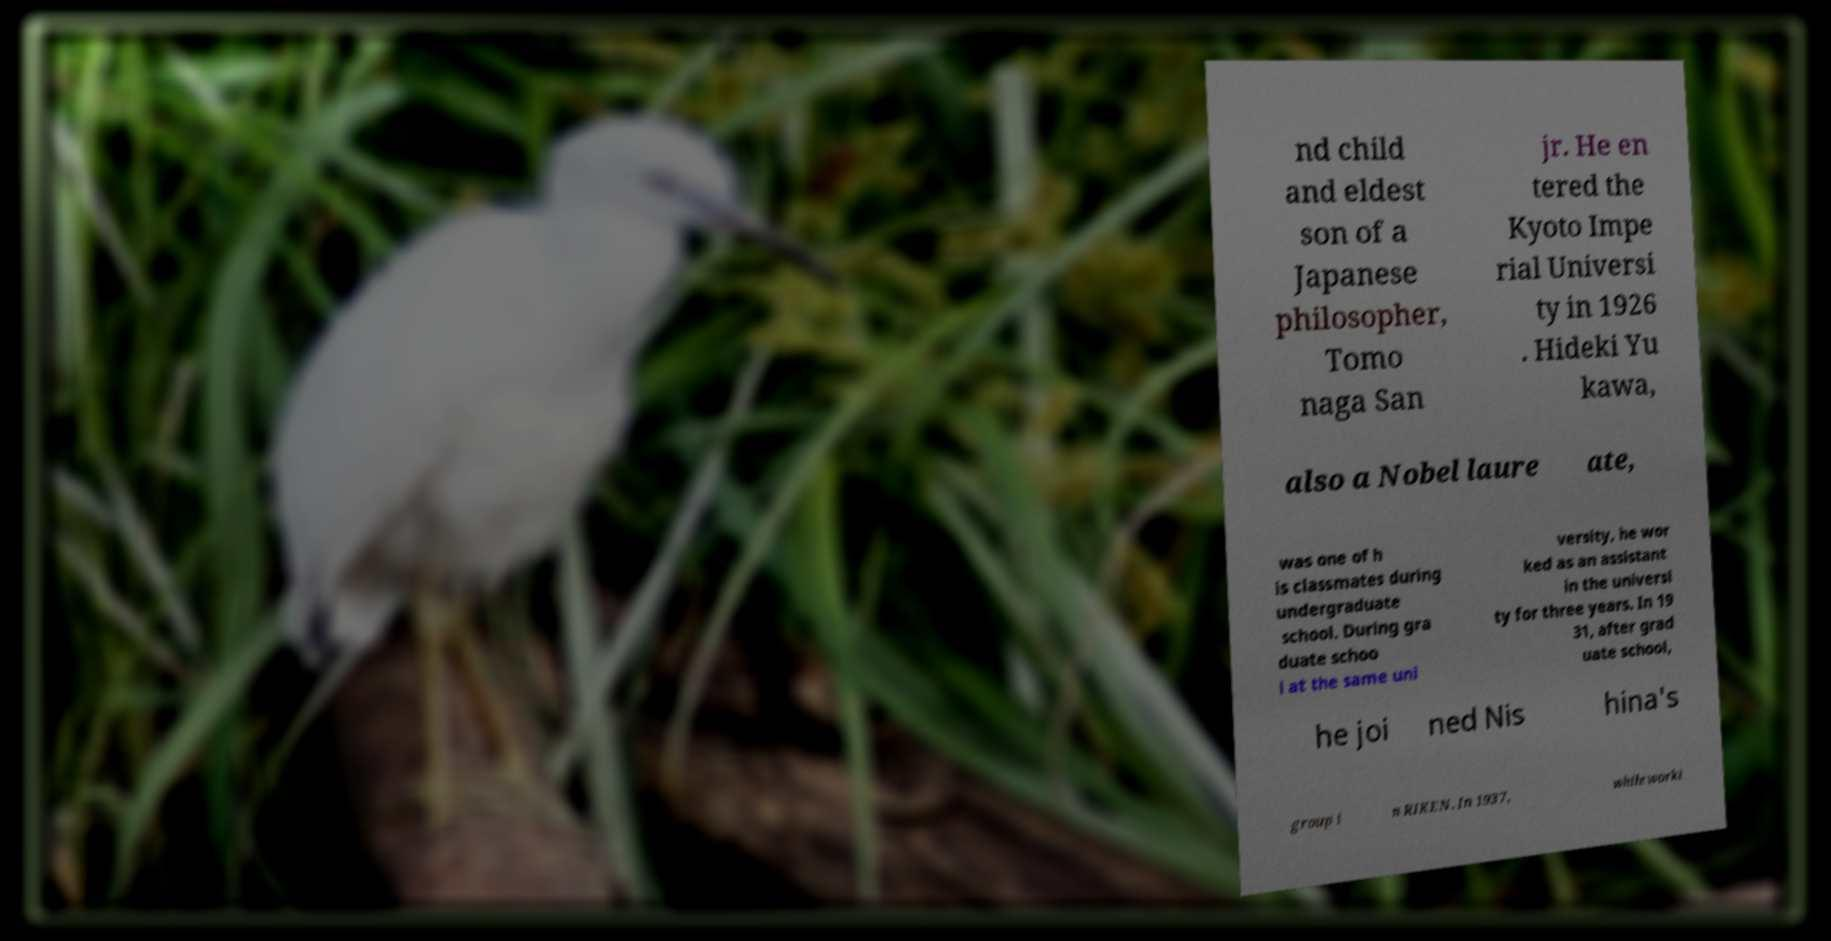I need the written content from this picture converted into text. Can you do that? nd child and eldest son of a Japanese philosopher, Tomo naga San jr. He en tered the Kyoto Impe rial Universi ty in 1926 . Hideki Yu kawa, also a Nobel laure ate, was one of h is classmates during undergraduate school. During gra duate schoo l at the same uni versity, he wor ked as an assistant in the universi ty for three years. In 19 31, after grad uate school, he joi ned Nis hina's group i n RIKEN. In 1937, while worki 